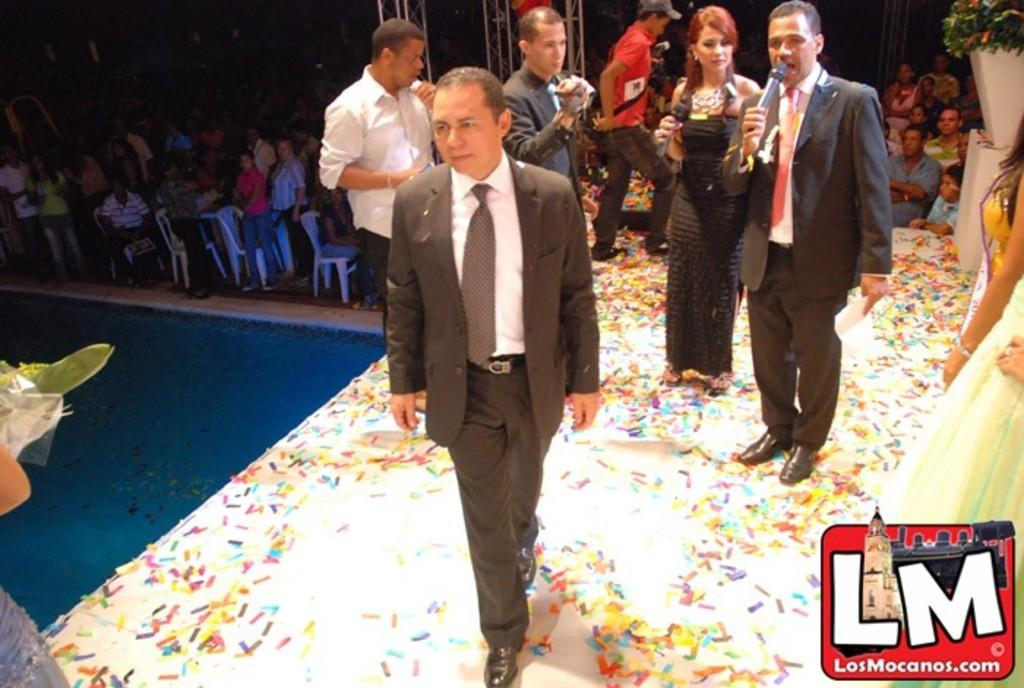How many people are in the image? There is a group of persons in the image. What are two of the persons doing in the image? Two persons are holding a persons are holding a mic in their hands. Can you describe the background of the image? There are additional persons and chairs in the background of the image. What type of soup is being served at the event in the image? There is no soup or event present in the image; it features a group of persons and two of them holding a mic. How old is the boy in the image? There is no boy present in the image. 